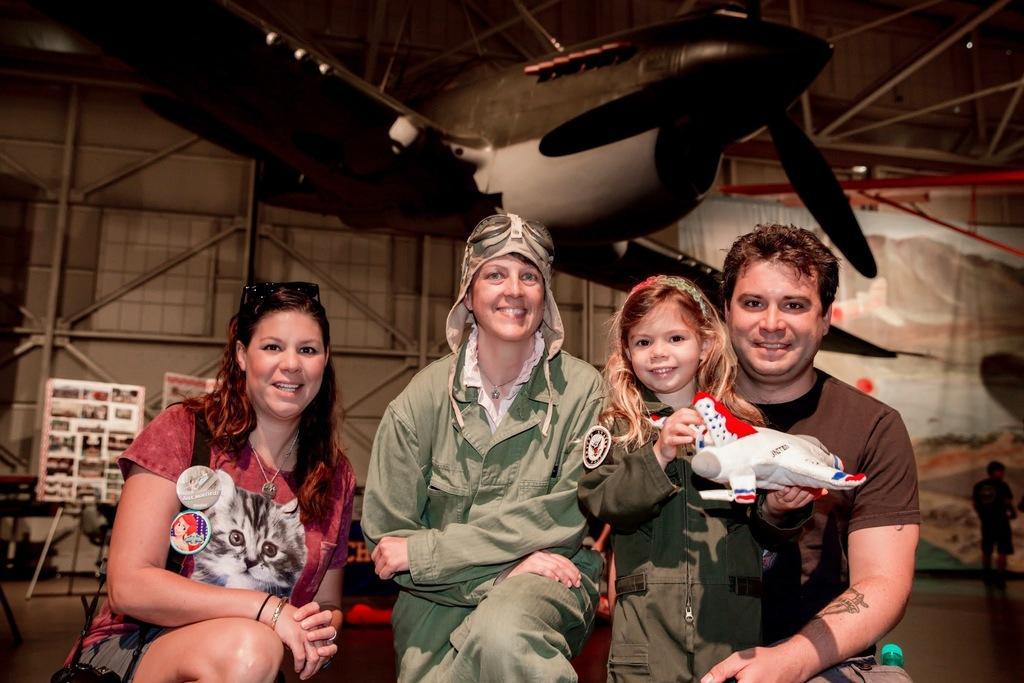In one or two sentences, can you explain what this image depicts? In this picture there are people smiling, among them there's a girl standing and holding an airplane. In the backgrounds of the image we can see airplane, boards, stand, rods, person and banner. 